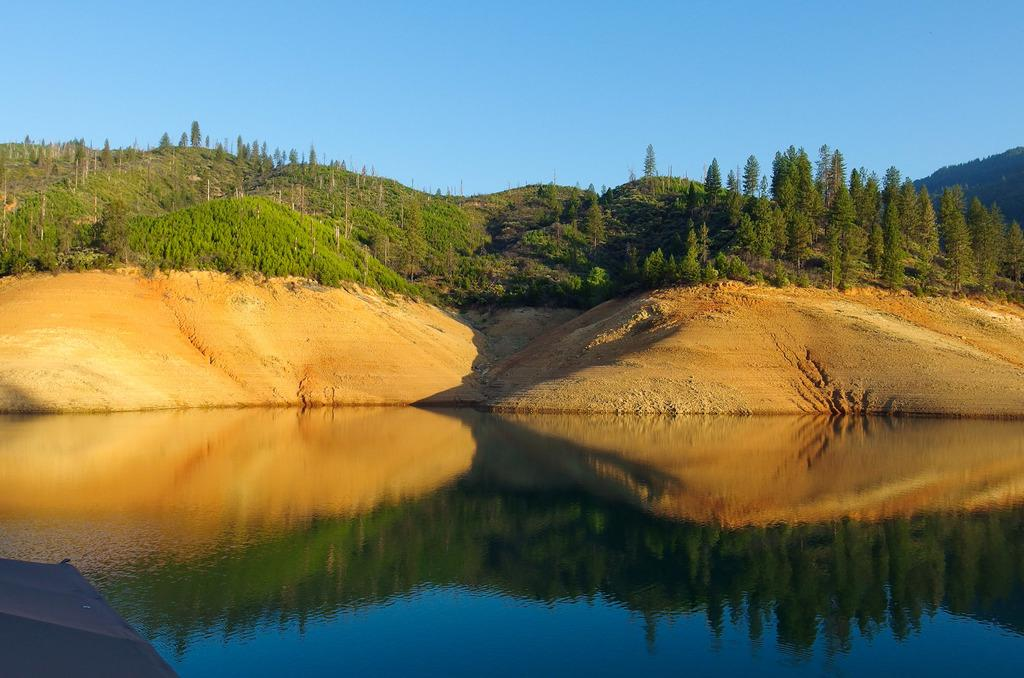What is present in the lake in the image? There is water in the lake in the image. What can be seen behind the water in the image? There are trees and mountains visible behind the water in the image. What type of wine is being served in the image? There is no wine present in the image; it features a lake with water and trees and mountains in the background. 